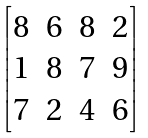Convert formula to latex. <formula><loc_0><loc_0><loc_500><loc_500>\begin{bmatrix} 8 & 6 & 8 & 2 \\ 1 & 8 & 7 & 9 \\ 7 & 2 & 4 & 6 \end{bmatrix}</formula> 